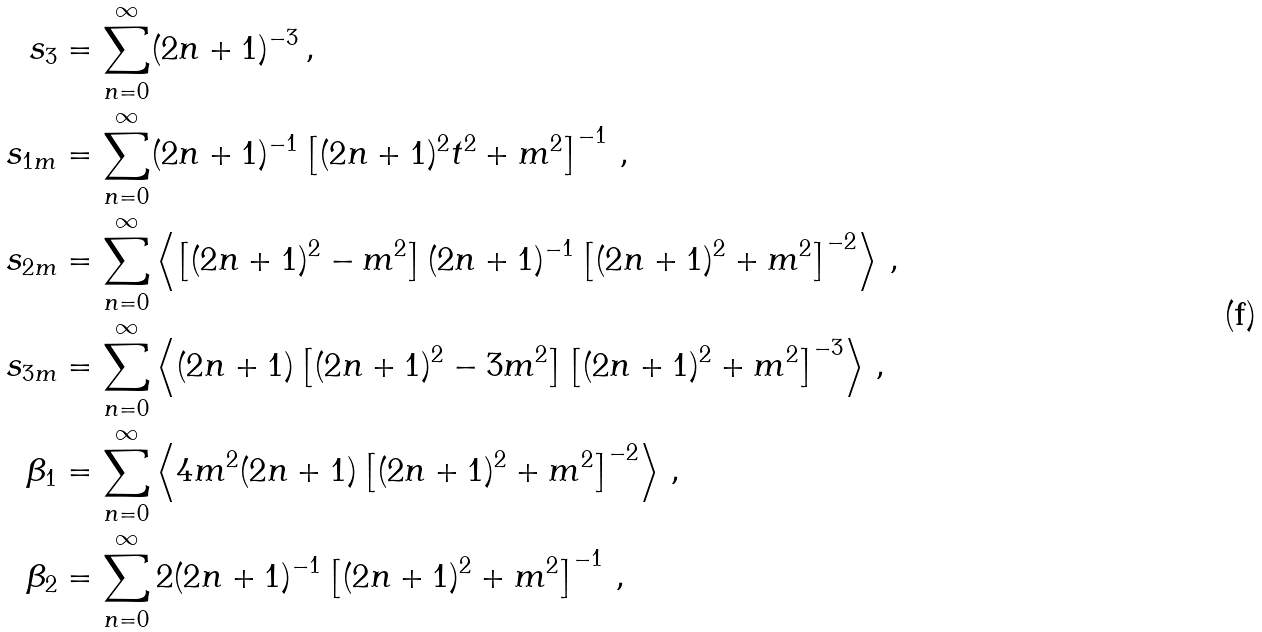Convert formula to latex. <formula><loc_0><loc_0><loc_500><loc_500>s _ { 3 } & = \sum _ { n = 0 } ^ { \infty } ( 2 n + 1 ) ^ { - 3 } \, , \\ s _ { 1 m } & = \sum _ { n = 0 } ^ { \infty } ( 2 n + 1 ) ^ { - 1 } \left [ ( 2 n + 1 ) ^ { 2 } t ^ { 2 } + m ^ { 2 } \right ] ^ { - 1 } \, , \\ s _ { 2 m } & = \sum _ { n = 0 } ^ { \infty } \left \langle \left [ ( 2 n + 1 ) ^ { 2 } - m ^ { 2 } \right ] ( 2 n + 1 ) ^ { - 1 } \left [ ( 2 n + 1 ) ^ { 2 } + m ^ { 2 } \right ] ^ { - 2 } \right \rangle \, , \\ s _ { 3 m } & = \sum _ { n = 0 } ^ { \infty } \left \langle ( 2 n + 1 ) \left [ ( 2 n + 1 ) ^ { 2 } - 3 m ^ { 2 } \right ] \left [ ( 2 n + 1 ) ^ { 2 } + m ^ { 2 } \right ] ^ { - 3 } \right \rangle \, , \\ \beta _ { 1 } & = \sum _ { n = 0 } ^ { \infty } \left \langle 4 m ^ { 2 } ( 2 n + 1 ) \left [ ( 2 n + 1 ) ^ { 2 } + m ^ { 2 } \right ] ^ { - 2 } \right \rangle \, , \\ \beta _ { 2 } & = \sum _ { n = 0 } ^ { \infty } 2 ( 2 n + 1 ) ^ { - 1 } \left [ ( 2 n + 1 ) ^ { 2 } + m ^ { 2 } \right ] ^ { - 1 } \, ,</formula> 